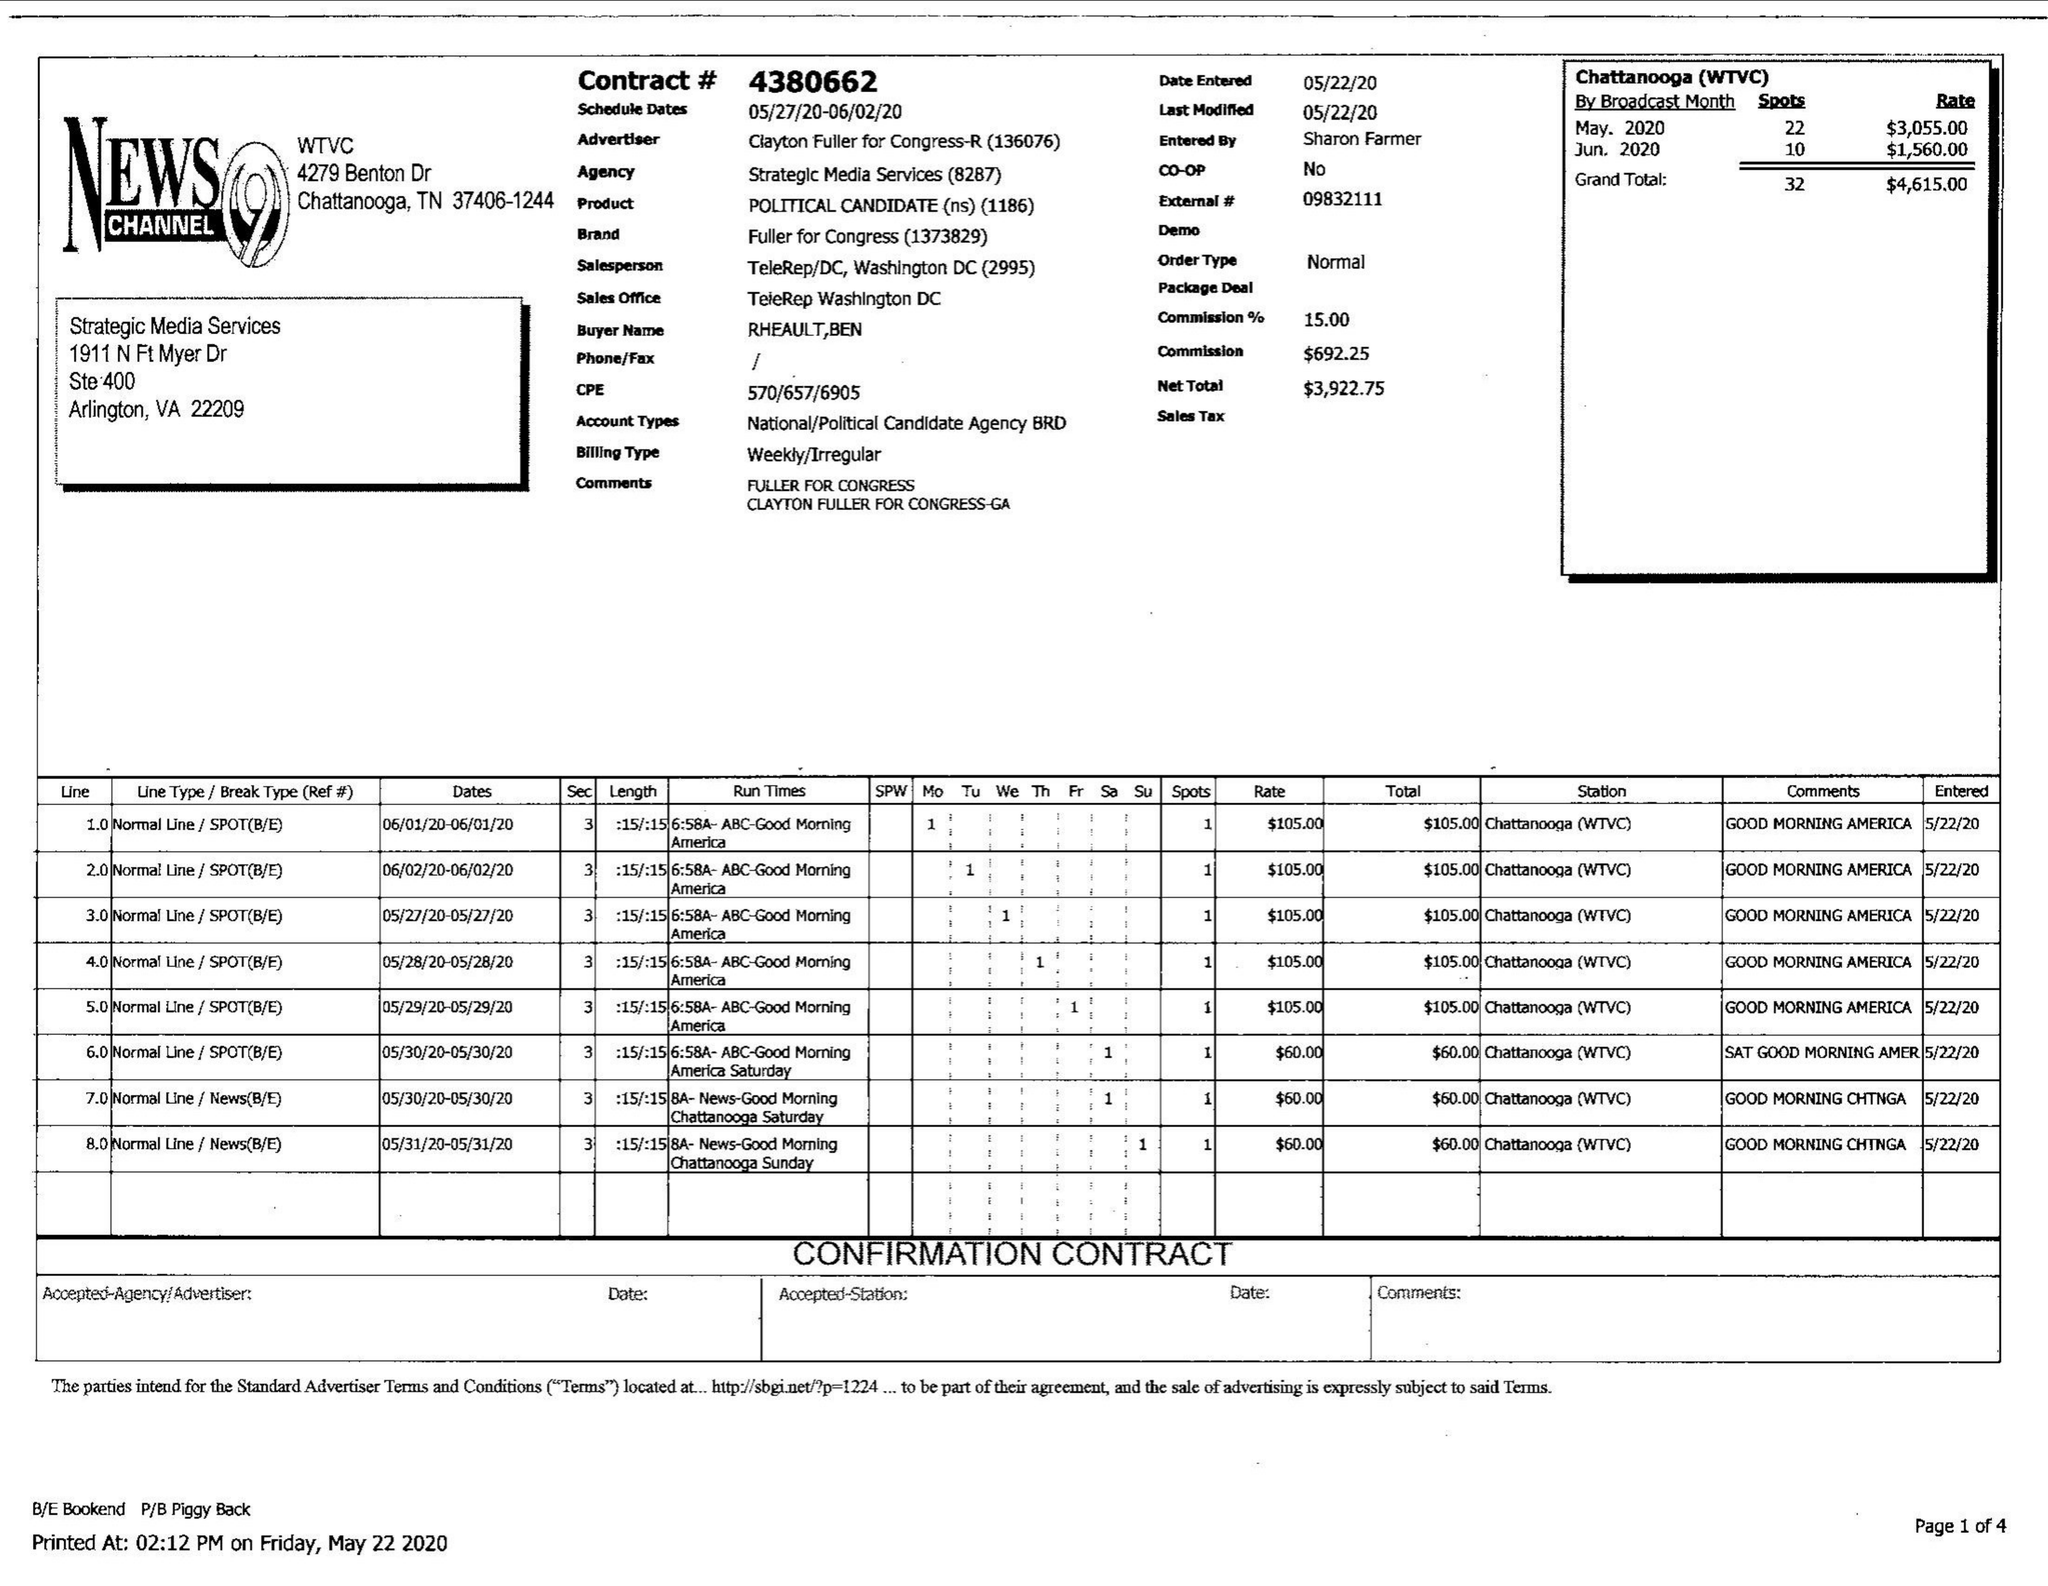What is the value for the flight_from?
Answer the question using a single word or phrase. 05/27/20 